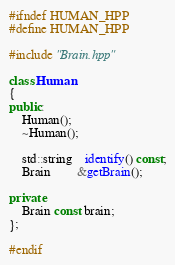Convert code to text. <code><loc_0><loc_0><loc_500><loc_500><_C++_>#ifndef HUMAN_HPP
#define HUMAN_HPP

#include "Brain.hpp"

class Human
{
public:
	Human();
	~Human();

	std::string	identify() const;
	Brain 		&getBrain();

private:
	Brain const brain;
};

#endif
</code> 